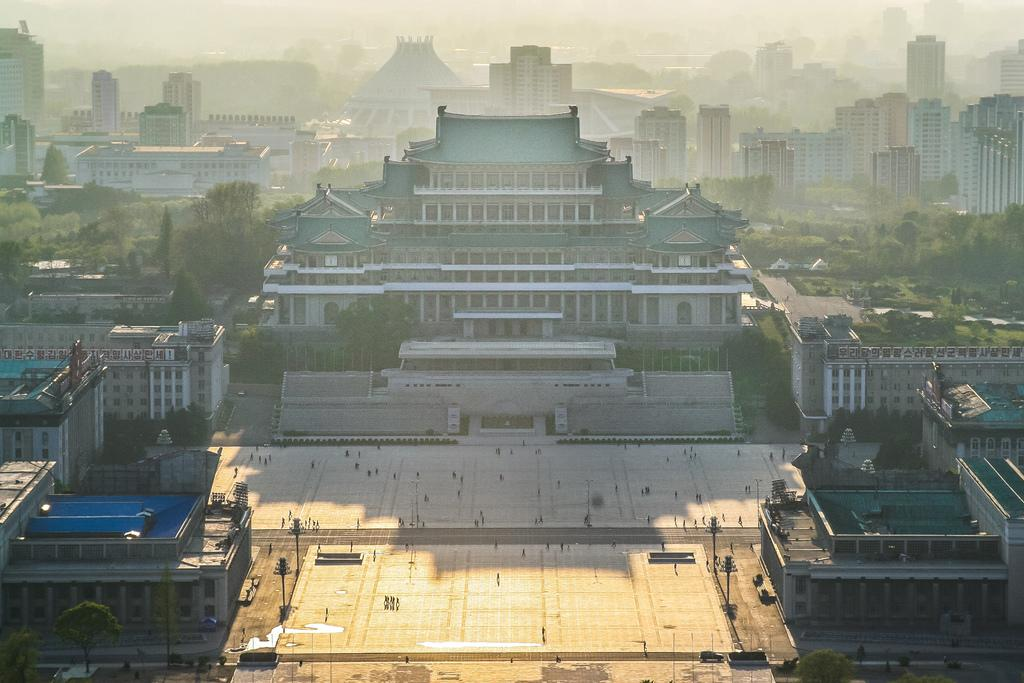What type of structures can be seen in the image? There are buildings in the image. What natural elements are present in the image? There are trees and grass in the image. What type of vegetation can be seen in the image? There are plants in the image. What is visible on the ground in the image? There are objects on the ground in the image. What are the poles used for in the image? The purpose of the poles in the image is not specified, but they could be for support or signage. What book is the father reading to the children in the image? There is no book or father present in the image; it features buildings, trees, plants, the ground, objects, and poles. 